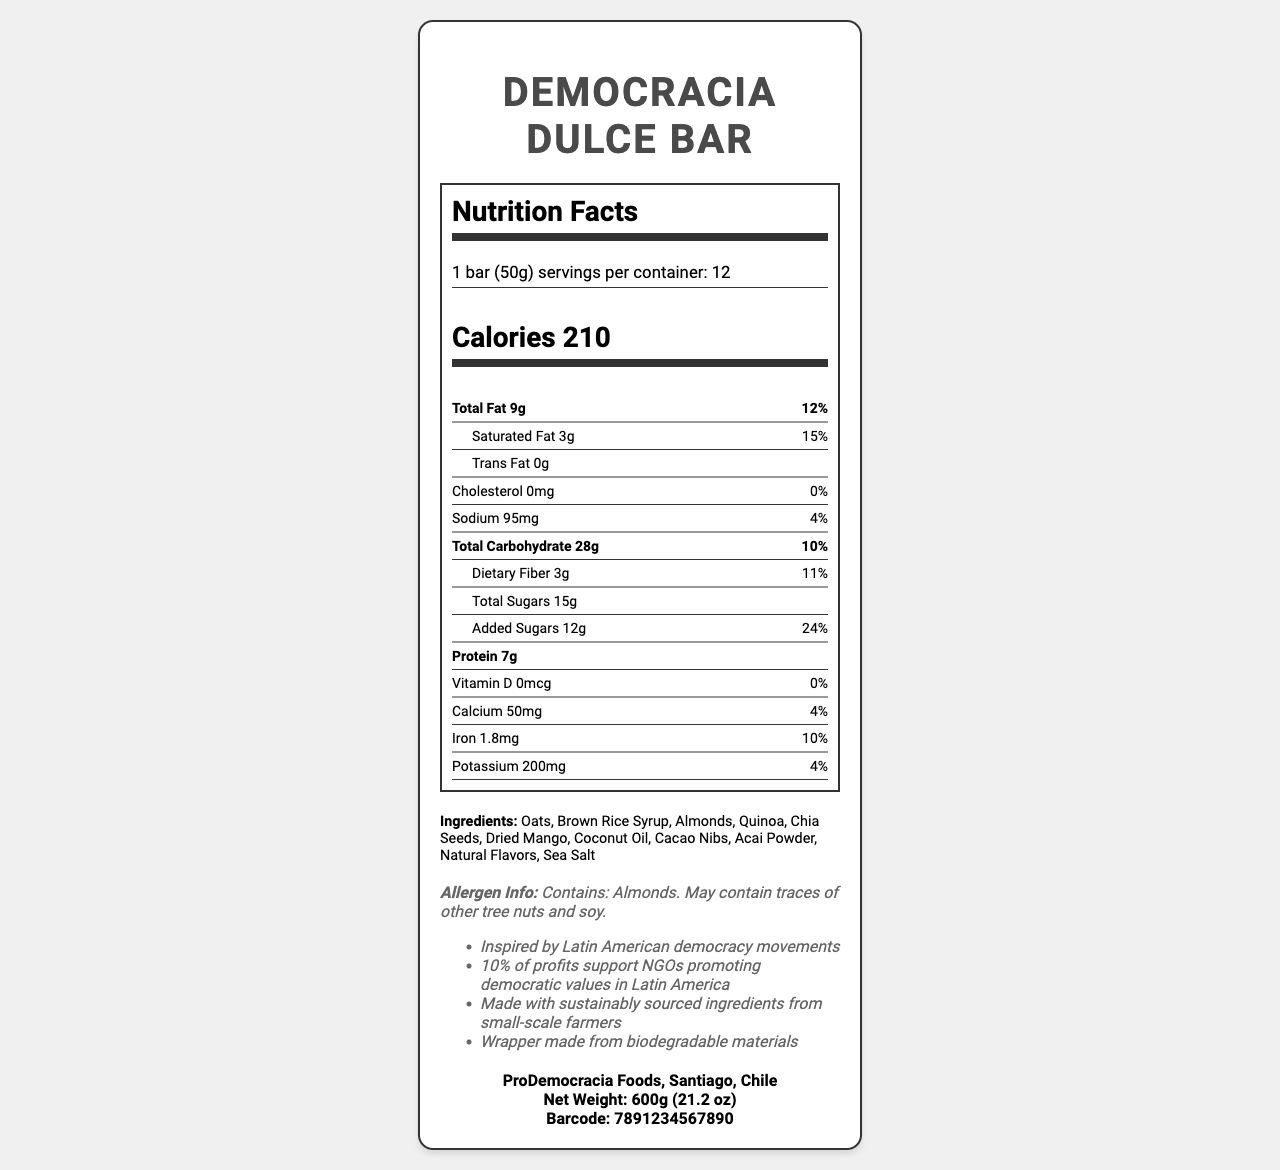what is the serving size? The serving size is listed as "1 bar (50g)" in the serving information section of the label.
Answer: 1 bar (50g) how many calories are in one serving? The number of calories per serving is stated as 210 in the calories section of the label.
Answer: 210 what is the total fat content per serving? The total fat content per serving is listed as 9g.
Answer: 9g what percentage of the daily value is the saturated fat content? It is mentioned that the saturated fat content represents 15% of the daily value.
Answer: 15% how much protein does each bar contain? Each bar contains 7g of protein, as noted in the protein section.
Answer: 7g which ingredient might cause an allergic reaction? A. Quinoa B. Almonds C. Brown Rice Syrup D. Sea Salt The allergen information specifies that the bar contains almonds.
Answer: B how much sodium is in a bar? The sodium content in one bar is 95mg.
Answer: 95mg how much dietary fiber does a single serving contain? A single serving contains 3g of dietary fiber.
Answer: 3g which nutrient has the highest daily value percentage? A. Total Carbohydrate B. Saturated Fat C. Sodium D. Added Sugars Added sugars have the highest daily value percentage at 24%.
Answer: D is the product made with sustainably sourced ingredients? The additional information mentions that the product is made with sustainably sourced ingredients from small-scale farmers.
Answer: Yes how much calcium is in a bar? The calcium content in a bar is 50mg, as specified in the nutrient section.
Answer: 50mg how many servings are in a container? There are 12 servings per container.
Answer: 12 where is ProDemocracia Foods located? The manufacturer information states that ProDemocracia Foods is located in Santiago, Chile.
Answer: Santiago, Chile what is the net weight of the container? The net weight of the container is listed as 600g (21.2 oz).
Answer: 600g (21.2 oz) which nutrients have a daily value percentage of 10%? Both Total Carbohydrate and Iron have daily value percentages of 10%.
Answer: Total Carbohydrate and Iron what is this bar inspired by? The additional information section notes that the bar is inspired by Latin American democracy movements.
Answer: Latin American democracy movements summarize the main idea of the document. The label presents comprehensive information about the nutritional content, allergen warnings, and other essential details about the Democracia Dulce Bar, emphasizing its inspiration from Latin American democracy movements and its support for NGOs promoting democratic values.
Answer: The document is a nutrition facts label for the Democracia Dulce Bar, highlighting its serving size, ingredients, nutritional content, and additional information about the product's origins and sustainability commitments. what is the barcode number? The barcode number listed on the label is 7891234567890.
Answer: 7891234567890 how much vitamin D is in a bar? The vitamin D content per bar is 0mcg, as indicated in the list of nutrients.
Answer: 0mcg does the product contain any trans fat? The document specifies that the trans fat content is 0g.
Answer: No what percentage of profits support NGOs promoting democratic values? The additional information section specifies that 10% of profits support NGOs promoting democratic values in Latin America.
Answer: 10% which ingredient is not listed in the bar? A. Chia Seeds B. Dried Mango C. Cashews D. Acai Powder Cashews are not listed as an ingredient in the bar.
Answer: C how many total sugars are in a bar? Each bar contains 15g of total sugars.
Answer: 15g what is the manufacturer's contact phone number? The document does not provide any phone number for the manufacturer.
Answer: Not enough information 